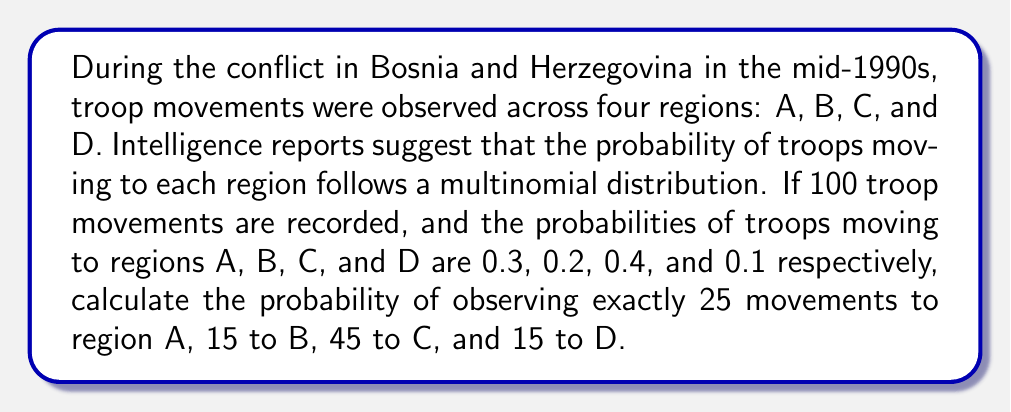Show me your answer to this math problem. To solve this problem, we'll use the multinomial probability mass function:

$$P(X_1 = x_1, X_2 = x_2, ..., X_k = x_k) = \frac{n!}{x_1! x_2! ... x_k!} p_1^{x_1} p_2^{x_2} ... p_k^{x_k}$$

Where:
$n$ = total number of trials (troop movements)
$x_i$ = number of occurrences for each outcome
$p_i$ = probability of each outcome

Given:
$n = 100$
$x_A = 25, x_B = 15, x_C = 45, x_D = 15$
$p_A = 0.3, p_B = 0.2, p_C = 0.4, p_D = 0.1$

Step 1: Substitute the values into the formula:

$$P(X_A = 25, X_B = 15, X_C = 45, X_D = 15) = \frac{100!}{25! 15! 45! 15!} (0.3)^{25} (0.2)^{15} (0.4)^{45} (0.1)^{15}$$

Step 2: Calculate the factorial terms:
$100! = 9.33262 \times 10^{157}$
$25! = 1.55112 \times 10^{25}$
$15! = 1.30767 \times 10^{12}$
$45! = 1.19622 \times 10^{56}$

Step 3: Calculate the power terms:
$(0.3)^{25} = 8.47288 \times 10^{-13}$
$(0.2)^{15} = 3.27680 \times 10^{-11}$
$(0.4)^{45} = 1.20893 \times 10^{-17}$
$(0.1)^{15} = 1 \times 10^{-15}$

Step 4: Substitute these values and calculate:

$$\frac{9.33262 \times 10^{157}}{(1.55112 \times 10^{25})(1.30767 \times 10^{12})(1.19622 \times 10^{56})(1.30767 \times 10^{12})} \times (8.47288 \times 10^{-13})(3.27680 \times 10^{-11})(1.20893 \times 10^{-17})(1 \times 10^{-15})$$

Step 5: Simplify and calculate the final probability:

$$= 0.0416$$
Answer: 0.0416 